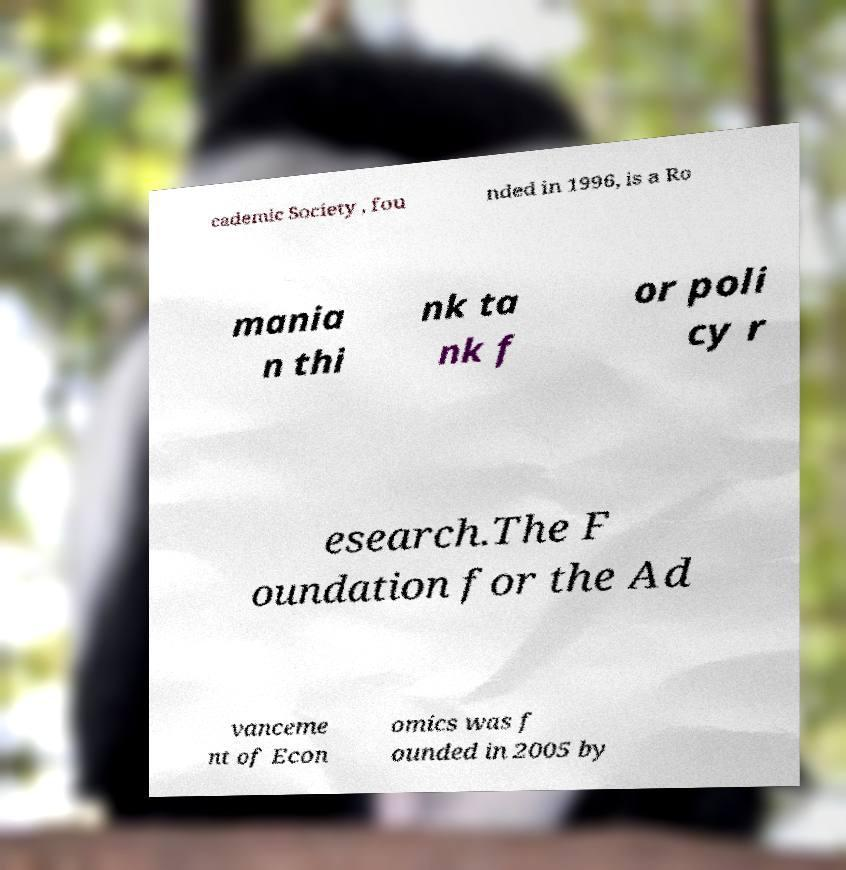For documentation purposes, I need the text within this image transcribed. Could you provide that? cademic Society , fou nded in 1996, is a Ro mania n thi nk ta nk f or poli cy r esearch.The F oundation for the Ad vanceme nt of Econ omics was f ounded in 2005 by 